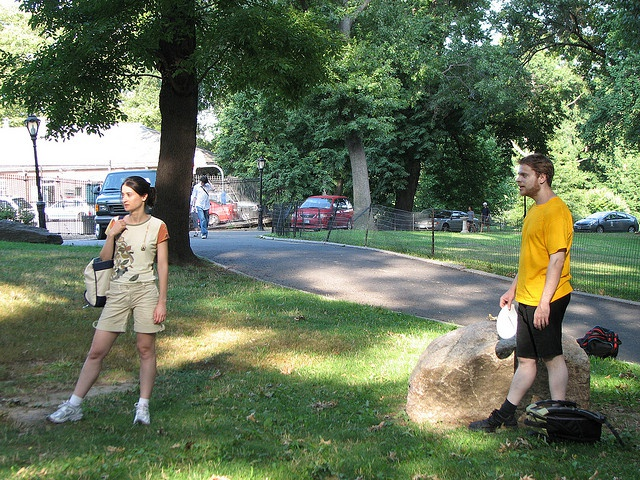Describe the objects in this image and their specific colors. I can see people in white, black, orange, darkgray, and gray tones, people in white, darkgray, gray, and ivory tones, handbag in white, black, gray, darkgray, and darkgreen tones, backpack in white, black, gray, darkgray, and darkgreen tones, and car in white, gray, black, brown, and purple tones in this image. 